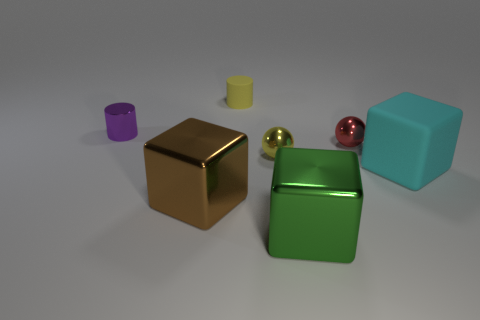How many matte cylinders are in front of the cube on the left side of the tiny yellow shiny thing?
Keep it short and to the point. 0. Is there any other thing that has the same material as the yellow sphere?
Ensure brevity in your answer.  Yes. What material is the small object that is in front of the small red sphere right of the matte object behind the large cyan block?
Your answer should be very brief. Metal. What is the material of the object that is both on the left side of the yellow cylinder and behind the large cyan cube?
Keep it short and to the point. Metal. What number of other matte things are the same shape as the large green object?
Make the answer very short. 1. What size is the matte object right of the metallic block that is to the right of the matte cylinder?
Give a very brief answer. Large. There is a rubber thing that is behind the tiny red sphere; is its color the same as the large metallic thing on the left side of the tiny rubber cylinder?
Give a very brief answer. No. How many yellow spheres are behind the small yellow thing that is in front of the rubber object that is left of the cyan matte object?
Keep it short and to the point. 0. What number of shiny objects are in front of the small red shiny object and behind the big brown shiny block?
Offer a terse response. 1. Is the number of tiny purple cylinders in front of the big brown cube greater than the number of red metal spheres?
Provide a short and direct response. No. 